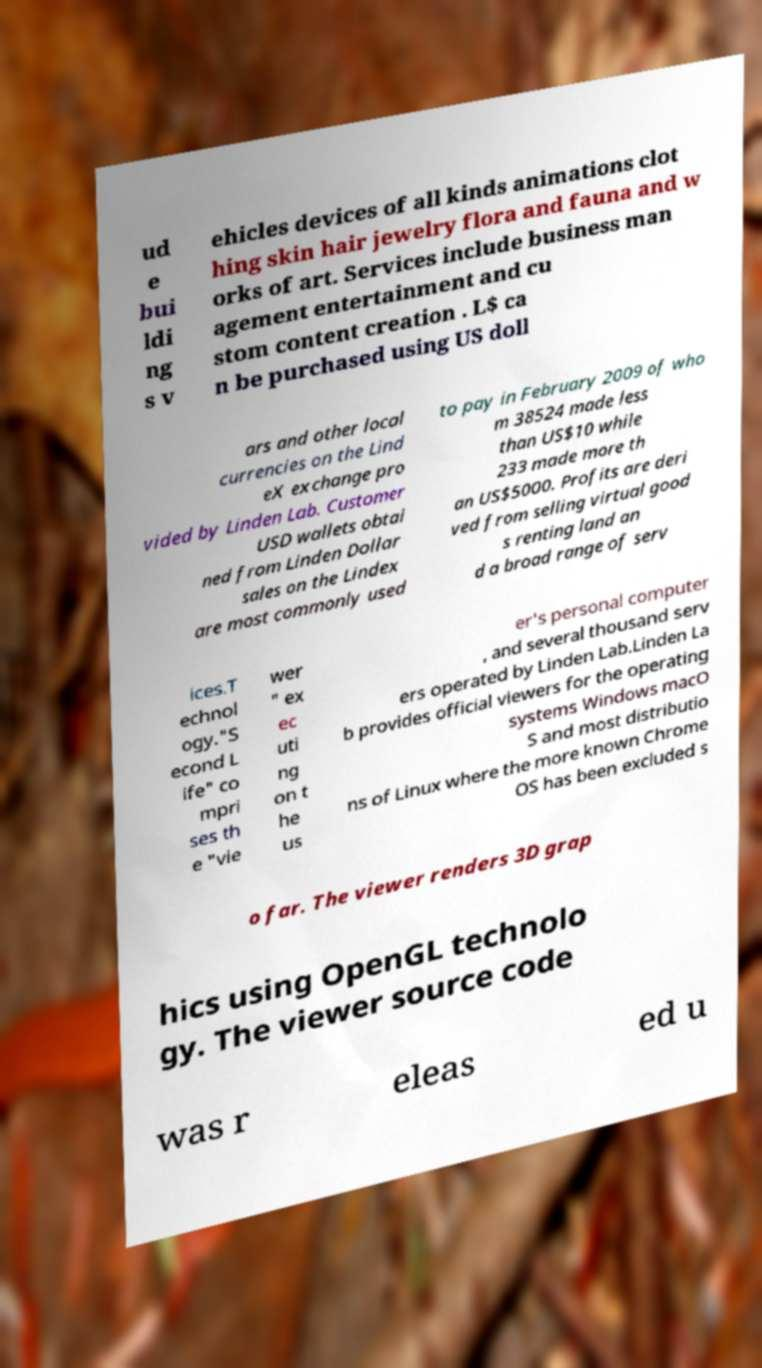Could you assist in decoding the text presented in this image and type it out clearly? ud e bui ldi ng s v ehicles devices of all kinds animations clot hing skin hair jewelry flora and fauna and w orks of art. Services include business man agement entertainment and cu stom content creation . L$ ca n be purchased using US doll ars and other local currencies on the Lind eX exchange pro vided by Linden Lab. Customer USD wallets obtai ned from Linden Dollar sales on the Lindex are most commonly used to pay in February 2009 of who m 38524 made less than US$10 while 233 made more th an US$5000. Profits are deri ved from selling virtual good s renting land an d a broad range of serv ices.T echnol ogy."S econd L ife" co mpri ses th e "vie wer " ex ec uti ng on t he us er's personal computer , and several thousand serv ers operated by Linden Lab.Linden La b provides official viewers for the operating systems Windows macO S and most distributio ns of Linux where the more known Chrome OS has been excluded s o far. The viewer renders 3D grap hics using OpenGL technolo gy. The viewer source code was r eleas ed u 